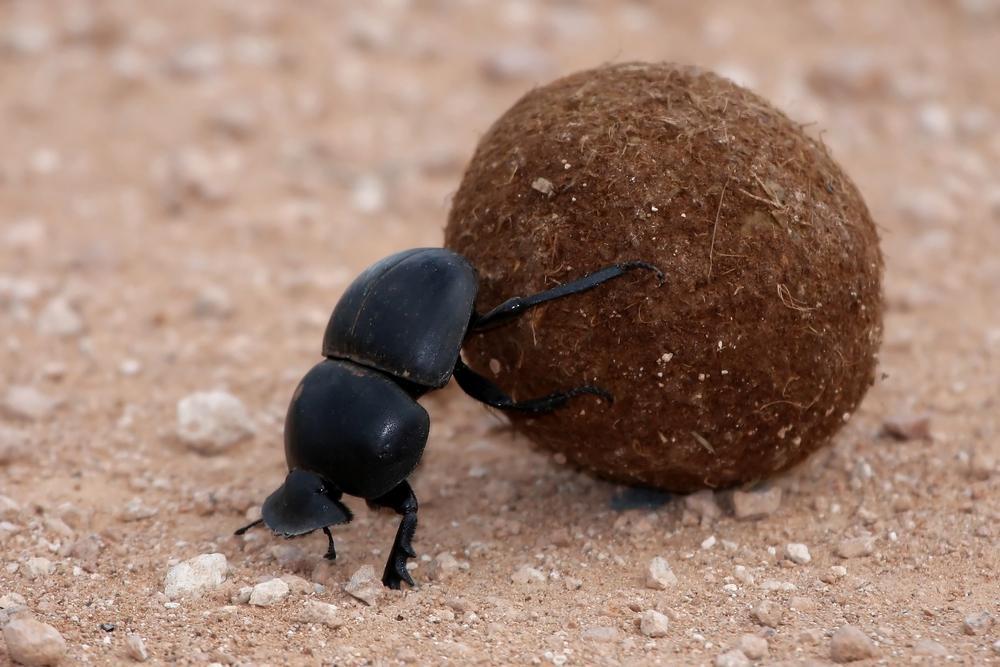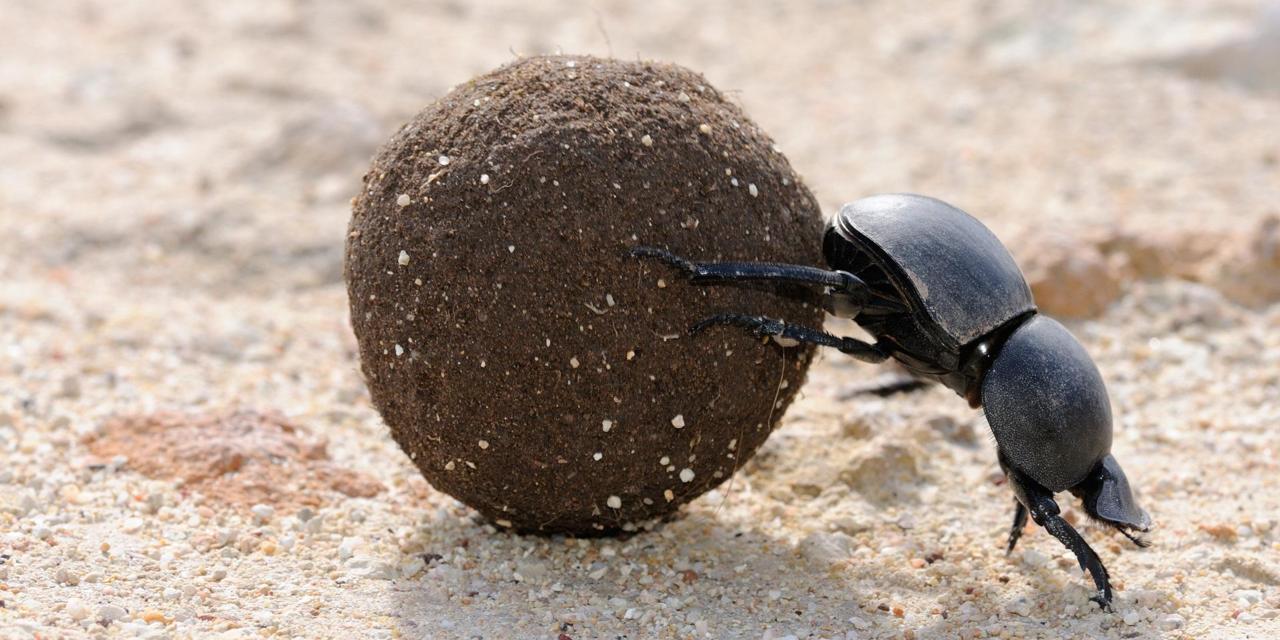The first image is the image on the left, the second image is the image on the right. Analyze the images presented: Is the assertion "There is a beetle that is not on a dung ball, in one image." valid? Answer yes or no. No. 